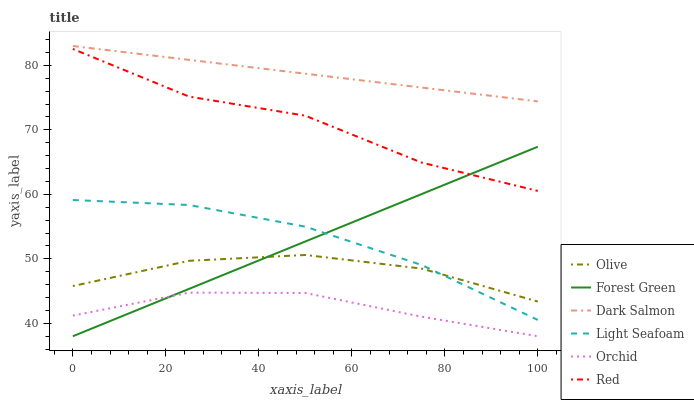Does Orchid have the minimum area under the curve?
Answer yes or no. Yes. Does Dark Salmon have the maximum area under the curve?
Answer yes or no. Yes. Does Forest Green have the minimum area under the curve?
Answer yes or no. No. Does Forest Green have the maximum area under the curve?
Answer yes or no. No. Is Dark Salmon the smoothest?
Answer yes or no. Yes. Is Red the roughest?
Answer yes or no. Yes. Is Forest Green the smoothest?
Answer yes or no. No. Is Forest Green the roughest?
Answer yes or no. No. Does Forest Green have the lowest value?
Answer yes or no. Yes. Does Olive have the lowest value?
Answer yes or no. No. Does Dark Salmon have the highest value?
Answer yes or no. Yes. Does Forest Green have the highest value?
Answer yes or no. No. Is Forest Green less than Dark Salmon?
Answer yes or no. Yes. Is Light Seafoam greater than Orchid?
Answer yes or no. Yes. Does Olive intersect Light Seafoam?
Answer yes or no. Yes. Is Olive less than Light Seafoam?
Answer yes or no. No. Is Olive greater than Light Seafoam?
Answer yes or no. No. Does Forest Green intersect Dark Salmon?
Answer yes or no. No. 